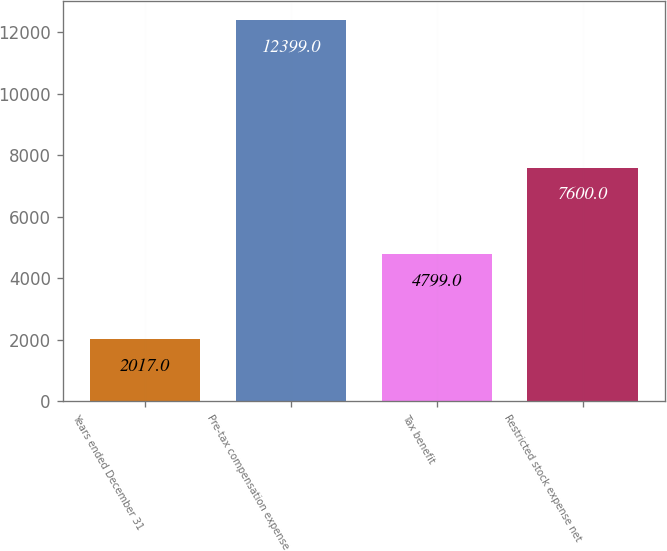Convert chart. <chart><loc_0><loc_0><loc_500><loc_500><bar_chart><fcel>Years ended December 31<fcel>Pre-tax compensation expense<fcel>Tax benefit<fcel>Restricted stock expense net<nl><fcel>2017<fcel>12399<fcel>4799<fcel>7600<nl></chart> 